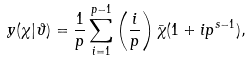<formula> <loc_0><loc_0><loc_500><loc_500>y ( \chi | \vartheta ) = \frac { 1 } { p } \sum _ { i = 1 } ^ { p - 1 } \left ( \frac { i } { p } \right ) \bar { \chi } ( 1 + i p ^ { s - 1 } ) ,</formula> 